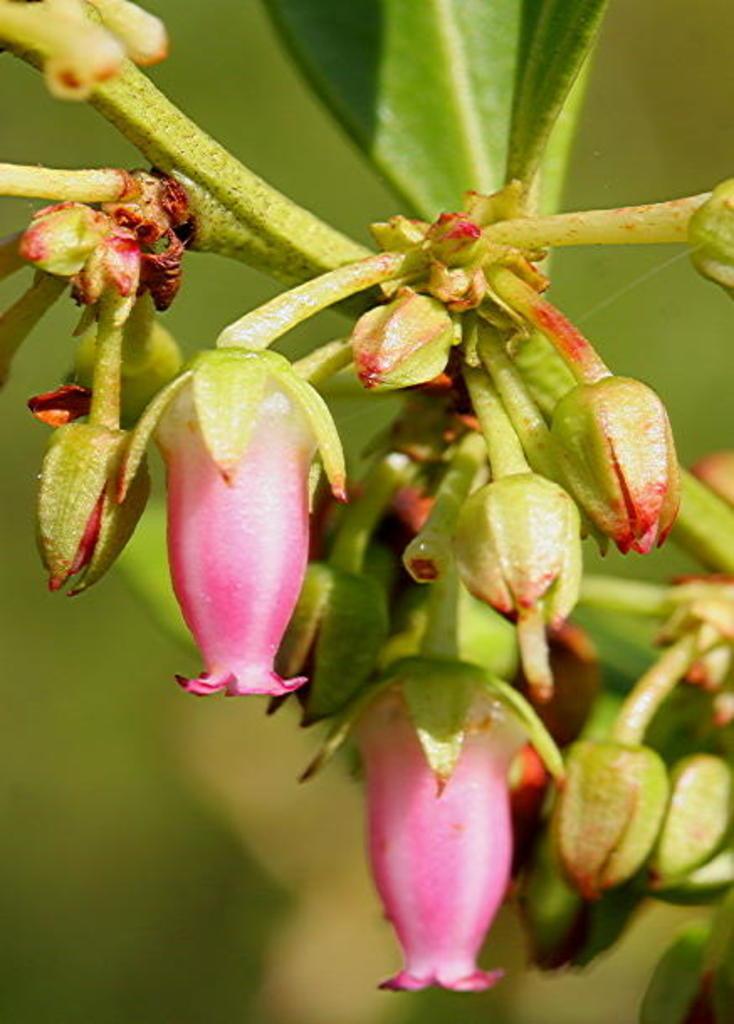In one or two sentences, can you explain what this image depicts? These are the flowers and buds. 